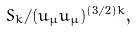<formula> <loc_0><loc_0><loc_500><loc_500>S _ { k } / ( u _ { \mu } u _ { \mu } ) ^ { ( 3 / 2 ) k } ,</formula> 